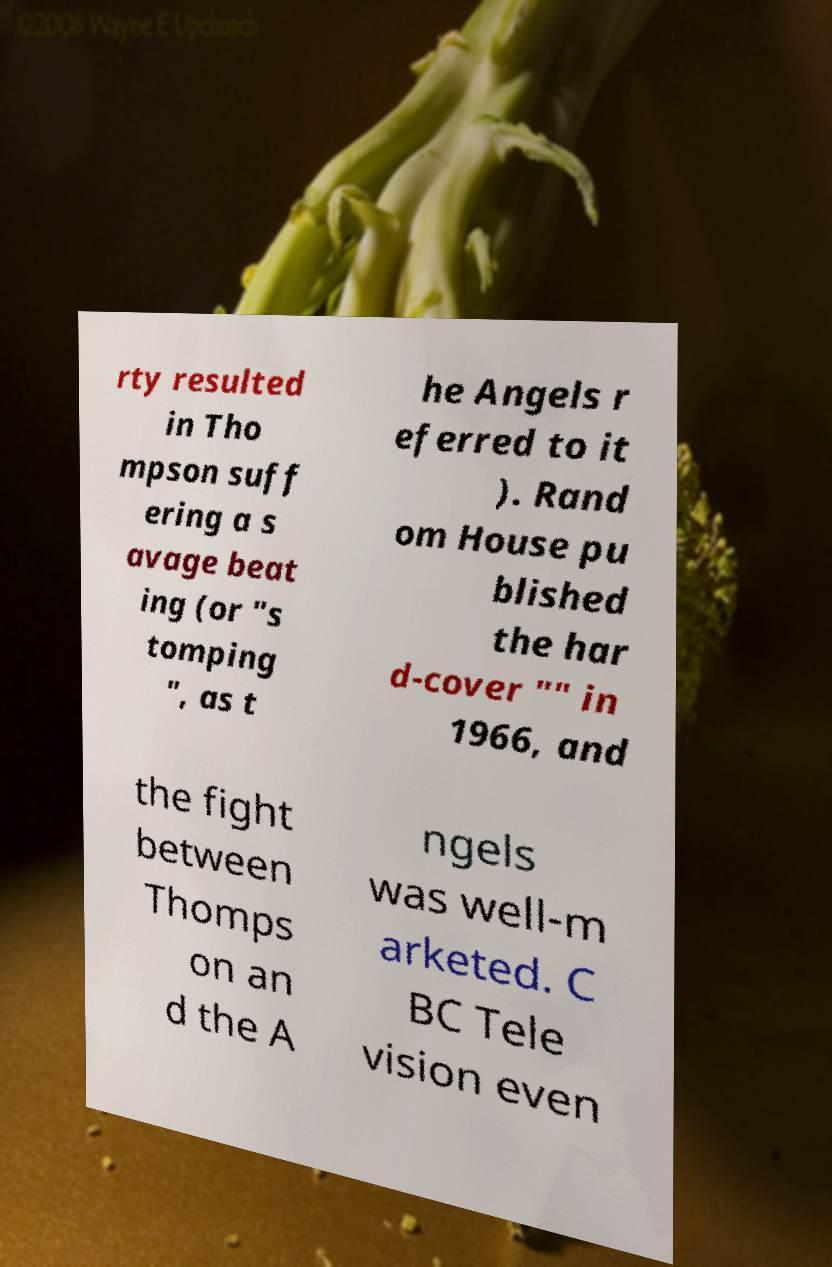There's text embedded in this image that I need extracted. Can you transcribe it verbatim? rty resulted in Tho mpson suff ering a s avage beat ing (or "s tomping ", as t he Angels r eferred to it ). Rand om House pu blished the har d-cover "" in 1966, and the fight between Thomps on an d the A ngels was well-m arketed. C BC Tele vision even 